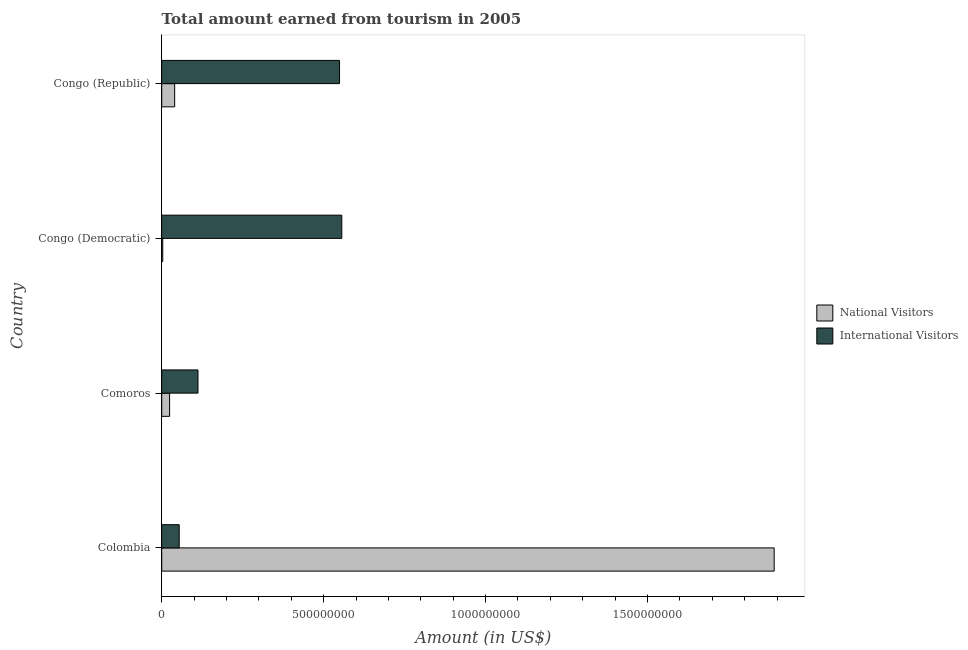How many different coloured bars are there?
Your answer should be very brief. 2. How many groups of bars are there?
Make the answer very short. 4. Are the number of bars per tick equal to the number of legend labels?
Your answer should be very brief. Yes. Are the number of bars on each tick of the Y-axis equal?
Keep it short and to the point. Yes. How many bars are there on the 3rd tick from the bottom?
Ensure brevity in your answer.  2. What is the label of the 1st group of bars from the top?
Give a very brief answer. Congo (Republic). What is the amount earned from international visitors in Congo (Democratic)?
Give a very brief answer. 5.56e+08. Across all countries, what is the maximum amount earned from national visitors?
Provide a short and direct response. 1.89e+09. Across all countries, what is the minimum amount earned from international visitors?
Provide a succinct answer. 5.40e+07. In which country was the amount earned from international visitors maximum?
Make the answer very short. Congo (Democratic). In which country was the amount earned from national visitors minimum?
Provide a succinct answer. Congo (Democratic). What is the total amount earned from international visitors in the graph?
Provide a short and direct response. 1.27e+09. What is the difference between the amount earned from international visitors in Comoros and that in Congo (Republic)?
Provide a succinct answer. -4.37e+08. What is the difference between the amount earned from international visitors in Colombia and the amount earned from national visitors in Congo (Democratic)?
Your answer should be compact. 5.08e+07. What is the average amount earned from national visitors per country?
Your answer should be compact. 4.90e+08. What is the difference between the amount earned from national visitors and amount earned from international visitors in Congo (Republic)?
Your answer should be compact. -5.09e+08. In how many countries, is the amount earned from international visitors greater than 1700000000 US$?
Your answer should be compact. 0. What is the ratio of the amount earned from national visitors in Colombia to that in Congo (Republic)?
Your answer should be very brief. 47.27. Is the difference between the amount earned from national visitors in Colombia and Congo (Democratic) greater than the difference between the amount earned from international visitors in Colombia and Congo (Democratic)?
Provide a succinct answer. Yes. What is the difference between the highest and the second highest amount earned from national visitors?
Offer a terse response. 1.85e+09. What is the difference between the highest and the lowest amount earned from national visitors?
Provide a succinct answer. 1.89e+09. In how many countries, is the amount earned from international visitors greater than the average amount earned from international visitors taken over all countries?
Provide a succinct answer. 2. Is the sum of the amount earned from national visitors in Colombia and Congo (Republic) greater than the maximum amount earned from international visitors across all countries?
Ensure brevity in your answer.  Yes. What does the 2nd bar from the top in Congo (Republic) represents?
Make the answer very short. National Visitors. What does the 2nd bar from the bottom in Comoros represents?
Your answer should be compact. International Visitors. Are all the bars in the graph horizontal?
Your answer should be compact. Yes. Are the values on the major ticks of X-axis written in scientific E-notation?
Your answer should be very brief. No. Does the graph contain any zero values?
Offer a very short reply. No. Where does the legend appear in the graph?
Your answer should be very brief. Center right. How many legend labels are there?
Provide a short and direct response. 2. How are the legend labels stacked?
Provide a succinct answer. Vertical. What is the title of the graph?
Offer a terse response. Total amount earned from tourism in 2005. Does "Tetanus" appear as one of the legend labels in the graph?
Ensure brevity in your answer.  No. What is the label or title of the X-axis?
Your response must be concise. Amount (in US$). What is the Amount (in US$) of National Visitors in Colombia?
Your answer should be compact. 1.89e+09. What is the Amount (in US$) of International Visitors in Colombia?
Offer a terse response. 5.40e+07. What is the Amount (in US$) of National Visitors in Comoros?
Your answer should be very brief. 2.44e+07. What is the Amount (in US$) of International Visitors in Comoros?
Your answer should be compact. 1.12e+08. What is the Amount (in US$) in National Visitors in Congo (Democratic)?
Offer a terse response. 3.20e+06. What is the Amount (in US$) of International Visitors in Congo (Democratic)?
Your response must be concise. 5.56e+08. What is the Amount (in US$) of National Visitors in Congo (Republic)?
Provide a succinct answer. 4.00e+07. What is the Amount (in US$) in International Visitors in Congo (Republic)?
Your answer should be compact. 5.49e+08. Across all countries, what is the maximum Amount (in US$) of National Visitors?
Your response must be concise. 1.89e+09. Across all countries, what is the maximum Amount (in US$) of International Visitors?
Make the answer very short. 5.56e+08. Across all countries, what is the minimum Amount (in US$) of National Visitors?
Offer a very short reply. 3.20e+06. Across all countries, what is the minimum Amount (in US$) in International Visitors?
Offer a very short reply. 5.40e+07. What is the total Amount (in US$) in National Visitors in the graph?
Provide a short and direct response. 1.96e+09. What is the total Amount (in US$) of International Visitors in the graph?
Make the answer very short. 1.27e+09. What is the difference between the Amount (in US$) of National Visitors in Colombia and that in Comoros?
Give a very brief answer. 1.87e+09. What is the difference between the Amount (in US$) in International Visitors in Colombia and that in Comoros?
Keep it short and to the point. -5.80e+07. What is the difference between the Amount (in US$) of National Visitors in Colombia and that in Congo (Democratic)?
Your answer should be very brief. 1.89e+09. What is the difference between the Amount (in US$) in International Visitors in Colombia and that in Congo (Democratic)?
Provide a short and direct response. -5.02e+08. What is the difference between the Amount (in US$) in National Visitors in Colombia and that in Congo (Republic)?
Offer a very short reply. 1.85e+09. What is the difference between the Amount (in US$) in International Visitors in Colombia and that in Congo (Republic)?
Provide a short and direct response. -4.95e+08. What is the difference between the Amount (in US$) in National Visitors in Comoros and that in Congo (Democratic)?
Your answer should be very brief. 2.12e+07. What is the difference between the Amount (in US$) of International Visitors in Comoros and that in Congo (Democratic)?
Offer a very short reply. -4.44e+08. What is the difference between the Amount (in US$) of National Visitors in Comoros and that in Congo (Republic)?
Keep it short and to the point. -1.56e+07. What is the difference between the Amount (in US$) of International Visitors in Comoros and that in Congo (Republic)?
Provide a short and direct response. -4.37e+08. What is the difference between the Amount (in US$) in National Visitors in Congo (Democratic) and that in Congo (Republic)?
Make the answer very short. -3.68e+07. What is the difference between the Amount (in US$) in International Visitors in Congo (Democratic) and that in Congo (Republic)?
Give a very brief answer. 7.00e+06. What is the difference between the Amount (in US$) of National Visitors in Colombia and the Amount (in US$) of International Visitors in Comoros?
Ensure brevity in your answer.  1.78e+09. What is the difference between the Amount (in US$) of National Visitors in Colombia and the Amount (in US$) of International Visitors in Congo (Democratic)?
Ensure brevity in your answer.  1.34e+09. What is the difference between the Amount (in US$) in National Visitors in Colombia and the Amount (in US$) in International Visitors in Congo (Republic)?
Make the answer very short. 1.34e+09. What is the difference between the Amount (in US$) in National Visitors in Comoros and the Amount (in US$) in International Visitors in Congo (Democratic)?
Make the answer very short. -5.32e+08. What is the difference between the Amount (in US$) in National Visitors in Comoros and the Amount (in US$) in International Visitors in Congo (Republic)?
Your response must be concise. -5.25e+08. What is the difference between the Amount (in US$) of National Visitors in Congo (Democratic) and the Amount (in US$) of International Visitors in Congo (Republic)?
Keep it short and to the point. -5.46e+08. What is the average Amount (in US$) in National Visitors per country?
Make the answer very short. 4.90e+08. What is the average Amount (in US$) of International Visitors per country?
Keep it short and to the point. 3.18e+08. What is the difference between the Amount (in US$) of National Visitors and Amount (in US$) of International Visitors in Colombia?
Keep it short and to the point. 1.84e+09. What is the difference between the Amount (in US$) of National Visitors and Amount (in US$) of International Visitors in Comoros?
Keep it short and to the point. -8.76e+07. What is the difference between the Amount (in US$) in National Visitors and Amount (in US$) in International Visitors in Congo (Democratic)?
Your answer should be compact. -5.53e+08. What is the difference between the Amount (in US$) in National Visitors and Amount (in US$) in International Visitors in Congo (Republic)?
Ensure brevity in your answer.  -5.09e+08. What is the ratio of the Amount (in US$) of National Visitors in Colombia to that in Comoros?
Your answer should be very brief. 77.5. What is the ratio of the Amount (in US$) of International Visitors in Colombia to that in Comoros?
Offer a very short reply. 0.48. What is the ratio of the Amount (in US$) in National Visitors in Colombia to that in Congo (Democratic)?
Keep it short and to the point. 590.94. What is the ratio of the Amount (in US$) of International Visitors in Colombia to that in Congo (Democratic)?
Ensure brevity in your answer.  0.1. What is the ratio of the Amount (in US$) of National Visitors in Colombia to that in Congo (Republic)?
Provide a succinct answer. 47.27. What is the ratio of the Amount (in US$) of International Visitors in Colombia to that in Congo (Republic)?
Your answer should be very brief. 0.1. What is the ratio of the Amount (in US$) of National Visitors in Comoros to that in Congo (Democratic)?
Provide a succinct answer. 7.62. What is the ratio of the Amount (in US$) of International Visitors in Comoros to that in Congo (Democratic)?
Offer a very short reply. 0.2. What is the ratio of the Amount (in US$) of National Visitors in Comoros to that in Congo (Republic)?
Ensure brevity in your answer.  0.61. What is the ratio of the Amount (in US$) in International Visitors in Comoros to that in Congo (Republic)?
Make the answer very short. 0.2. What is the ratio of the Amount (in US$) of International Visitors in Congo (Democratic) to that in Congo (Republic)?
Your response must be concise. 1.01. What is the difference between the highest and the second highest Amount (in US$) of National Visitors?
Keep it short and to the point. 1.85e+09. What is the difference between the highest and the lowest Amount (in US$) in National Visitors?
Your answer should be compact. 1.89e+09. What is the difference between the highest and the lowest Amount (in US$) in International Visitors?
Offer a terse response. 5.02e+08. 